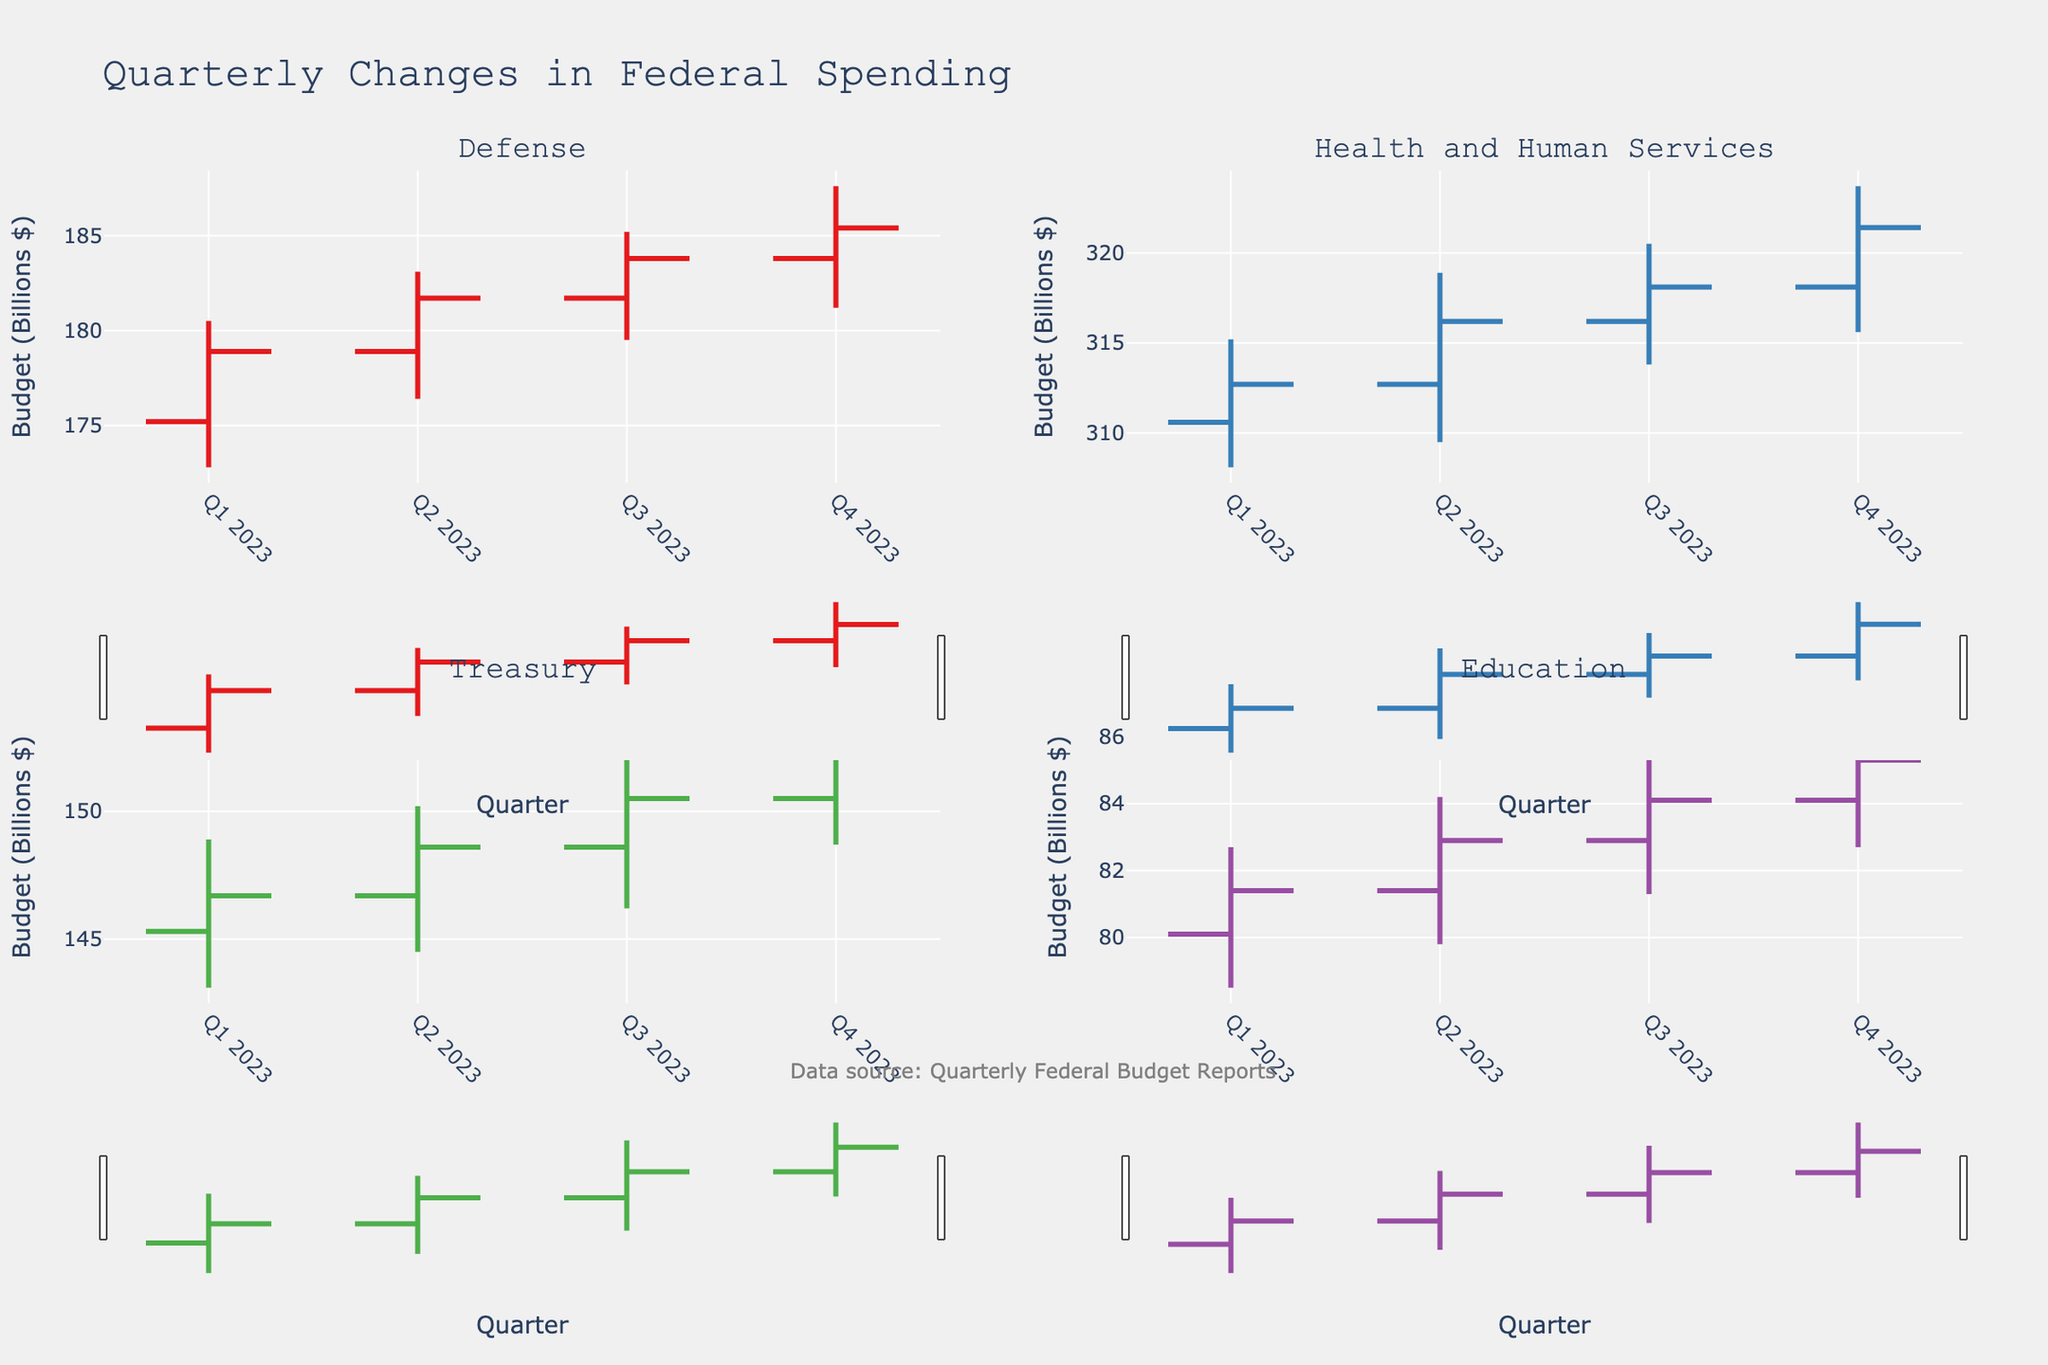Which department had the highest budget increase in Q4 2023? To find this, compare the Close values for Q4 2023. Defense: 185.4, Health and Human Services: 321.4, Treasury: 152.3, Education: 85.3. Health and Human Services has the highest Close value.
Answer: Health and Human Services What was the lowest budget point for the Education department in Q3 2023? Look at the Low value for Education in Q3 2023, which is specifically 81.3.
Answer: 81.3 Between Q3 and Q4 2023, which department saw the greatest increase in its budget? Calculate the difference between the Close values in Q4 and Q3 for each department. Defense: 185.4 - 183.8 = 1.6, Health and Human Services: 321.4 - 318.1 = 3.3, Treasury: 152.3 - 150.5 = 1.8, Education: 85.3 - 84.1 = 1.2. Health and Human Services has the highest increase.
Answer: Health and Human Services Did the Defense department ever see a quarter where its budget decreased? Compare the Close value of each quarter with the previous one: Q1: 178.9, Q2: 181.7, Q3: 183.8, Q4: 185.4. Each quarter's Close value is higher than the previous one, indicating no decrease.
Answer: No Which department had the most stable budget in 2023 based on the range between its high and low values? Calculate the range (High - Low) for each department over all quarters and find the average. Defense: (180.5-172.8) + (183.1-176.4) + (185.2-179.5) + (187.6-181.2) = 31.7, average = 31.7/4 = 7.925. Health and Human Services: (315.2-308.1) + (318.9-309.5) + (320.5-313.8) + (323.7-315.6) = 31.3, average = 31.3/4 = 7.825. Treasury: (148.9-143.1) + (150.2-144.5) + (152.8-146.2) + (154.1-148.7) = 23.4, average = 23.4/4 = 5.85. Education: (82.7-78.5) + (84.2-79.8) + (85.6-81.3) + (86.9-82.7) = 16.6, average = 16.6/4 = 4.15. Education has the smallest average range.
Answer: Education What was the highest budget recorded for the Treasury department in 2023? The High value for each quarter for Treasury are Q1: 148.9, Q2: 150.2, Q3: 152.8, Q4: 154.1. The highest of these is 154.1.
Answer: 154.1 During which quarter did Health and Human Services have the smallest range between its high and low budget values? Calculate (High - Low) for Health and Human Services in each quarter. Q1: 315.2-308.1=7.1, Q2: 318.9-309.5=9.4, Q3: 320.5-313.8=6.7, Q4: 323.7-315.6=8.1. The smallest range is 6.7 in Q3.
Answer: Q3 2023 For the entire year, which department had the most consistent upward trend in its budget? Compare the Open and Close values for each quarter across the year. Defense: O: 175.2, C: 178.9 -> O: 178.9, C: 181.7 -> O: 181.7, C: 183.8 -> O: 183.8, C: 185.4. All quarters consistently increase. Health and Human Services, Treasury, and Education also show increases but with more fluctuations. Defense had the most consistent upward trend.
Answer: Defense 